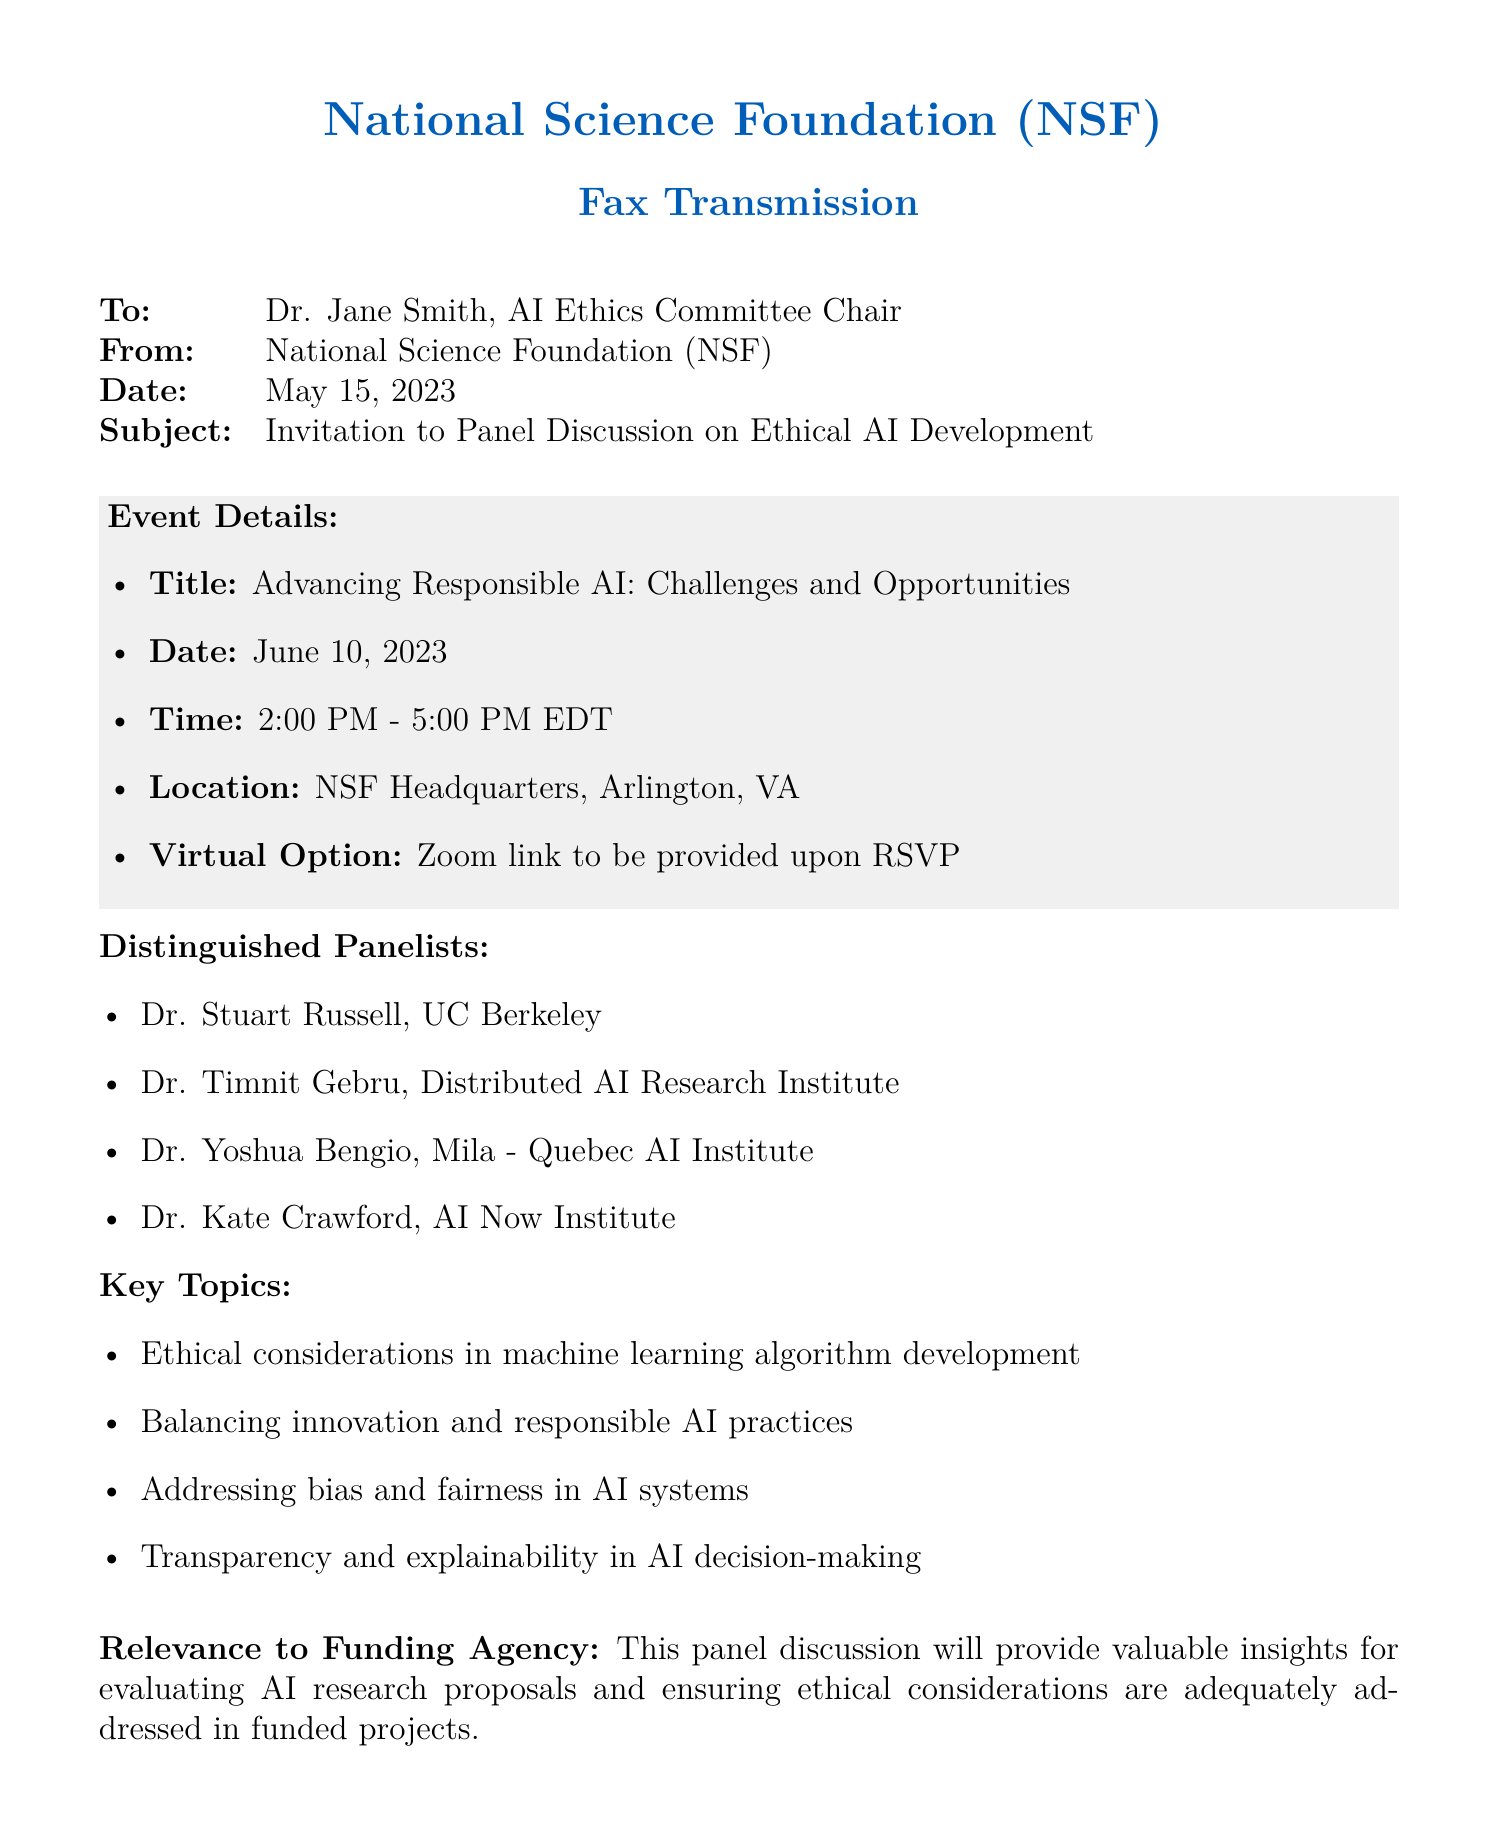what is the title of the panel discussion? The title is the main subject theme of the event as presented in the document.
Answer: Advancing Responsible AI: Challenges and Opportunities who are the distinguished panelists? The distinguished panelists are individuals listed in the document as speakers for the event.
Answer: Dr. Stuart Russell, Dr. Timnit Gebru, Dr. Yoshua Bengio, Dr. Kate Crawford when is the RSVP deadline? The RSVP deadline is specified in the document as the last date to confirm attendance.
Answer: May 31, 2023 what is the location of the panel discussion? The location is provided in the document as the venue for the event.
Answer: NSF Headquarters, Arlington, VA why is this panel discussion relevant to the funding agency? The document states the importance of the event for the funding agency in terms of proposal evaluation.
Answer: Valuable insights for evaluating AI research proposals what time does the panel discussion start? The start time is mentioned in the document as part of the event details.
Answer: 2:00 PM how will attendees join the discussion virtually? The virtual participation method is mentioned in the document regarding options for attendees.
Answer: Zoom link to be provided upon RSVP what subject should be included in the RSVP email? The document specifies the required subject line to be used for the RSVP email.
Answer: RSVP: Ethical AI Panel Discussion 